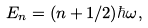Convert formula to latex. <formula><loc_0><loc_0><loc_500><loc_500>E _ { n } = ( n + 1 / 2 ) \hbar { \omega } ,</formula> 